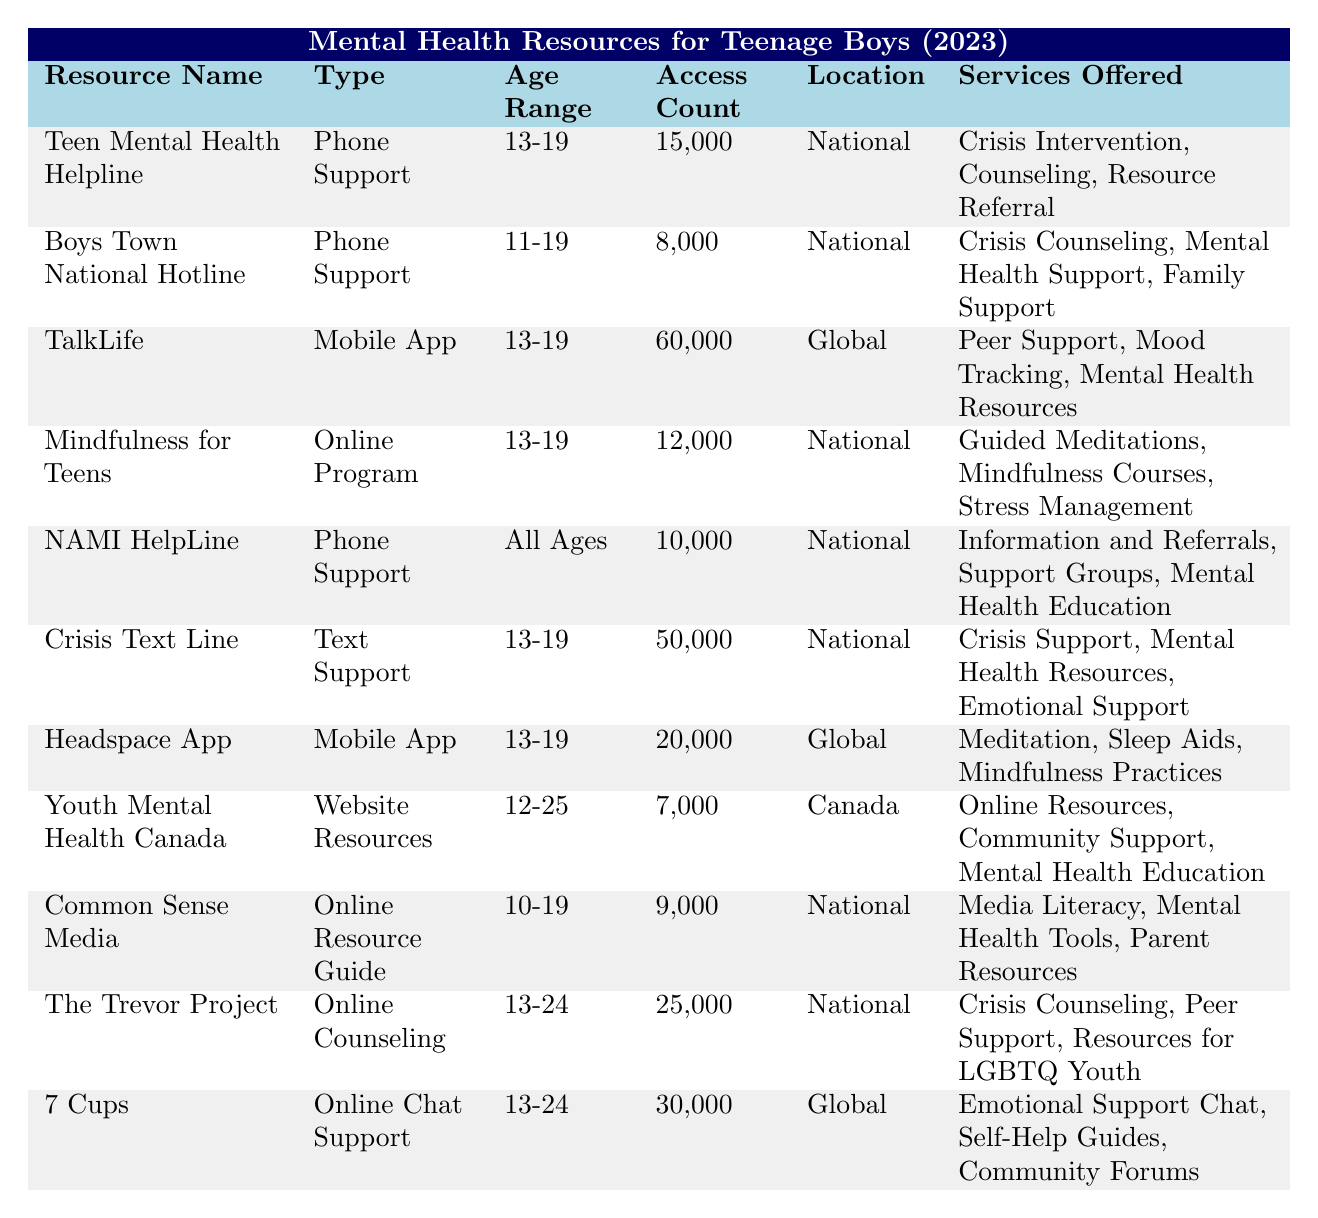What is the most accessed mental health resource by teenage boys in 2023? The highest access count in the table is 60,000 for the resource "TalkLife."
Answer: TalkLife How many teenage boys accessed the Crisis Text Line in 2023? The access count for the Crisis Text Line is listed as 50,000.
Answer: 50,000 Which resource offers services specifically for LGBTQ youth? The Trevor Project is indicated to provide resources for LGBTQ youth and offers online counseling.
Answer: The Trevor Project What is the total access count for the mobile apps listed in the table? The access counts for mobile apps are TalkLife (60,000), Headspace App (20,000), totaling 80,000.
Answer: 80,000 Did Boys Town National Hotline provide support for all ages? No, Boys Town National Hotline is specific to ages 11-19, not all ages.
Answer: No What is the location of the "Youth Mental Health Canada" resource? The table indicates that Youth Mental Health Canada is located in Canada.
Answer: Canada Which type of support has the highest combined access count? Phone Support resources include Teen Mental Health Helpline (15,000), Boys Town National Hotline (8,000), and NAMI HelpLine (10,000), totaling 33,000; while Text Support has Crisis Text Line (50,000). Text Support has the highest access count.
Answer: Text Support How many resources provide peer support? The resources that offer peer support are TalkLife, The Trevor Project, and 7 Cups. This totals three resources.
Answer: Three resources What is the average access count of the online support resources? The access counts for online support resources are Mindfulness for Teens (12,000), Common Sense Media (9,000), The Trevor Project (25,000), and 7 Cups (30,000). The total is 76,000, and there are four resources, making the average 76,000/4 = 19,000.
Answer: 19,000 Is the Teen Mental Health Helpline among the resources offering crisis intervention? Yes, the Teen Mental Health Helpline is listed as offering crisis intervention.
Answer: Yes What percentage of total accesses did the "TalkLife" app account for? The total access count across all resources is 261,000 (sum of all access counts). TalkLife has 60,000 accesses, so (60,000/261,000)*100 ≈ 22.9%.
Answer: Approximately 22.9% 